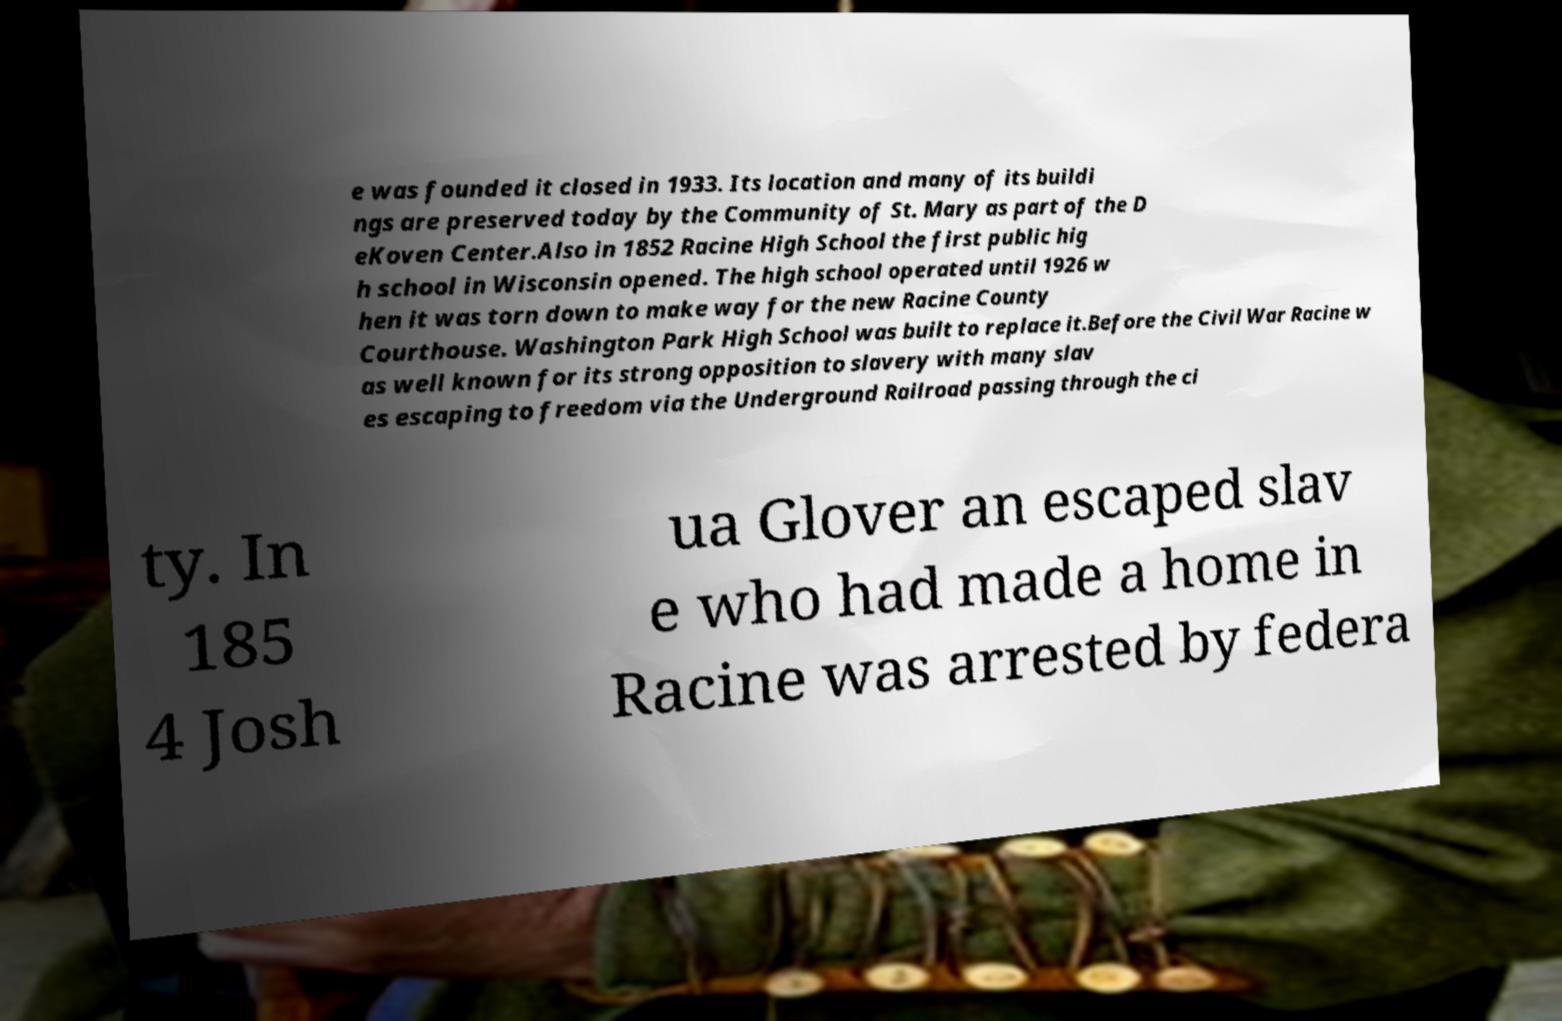Could you assist in decoding the text presented in this image and type it out clearly? e was founded it closed in 1933. Its location and many of its buildi ngs are preserved today by the Community of St. Mary as part of the D eKoven Center.Also in 1852 Racine High School the first public hig h school in Wisconsin opened. The high school operated until 1926 w hen it was torn down to make way for the new Racine County Courthouse. Washington Park High School was built to replace it.Before the Civil War Racine w as well known for its strong opposition to slavery with many slav es escaping to freedom via the Underground Railroad passing through the ci ty. In 185 4 Josh ua Glover an escaped slav e who had made a home in Racine was arrested by federa 